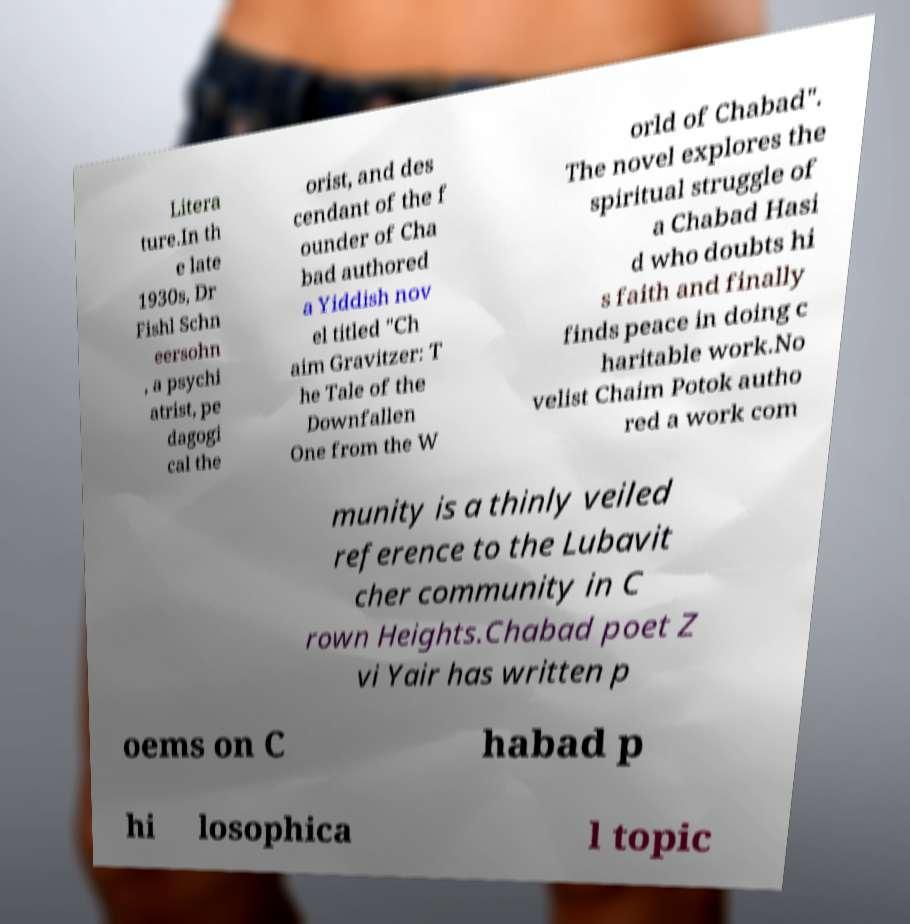Could you extract and type out the text from this image? Litera ture.In th e late 1930s, Dr Fishl Schn eersohn , a psychi atrist, pe dagogi cal the orist, and des cendant of the f ounder of Cha bad authored a Yiddish nov el titled "Ch aim Gravitzer: T he Tale of the Downfallen One from the W orld of Chabad". The novel explores the spiritual struggle of a Chabad Hasi d who doubts hi s faith and finally finds peace in doing c haritable work.No velist Chaim Potok autho red a work com munity is a thinly veiled reference to the Lubavit cher community in C rown Heights.Chabad poet Z vi Yair has written p oems on C habad p hi losophica l topic 